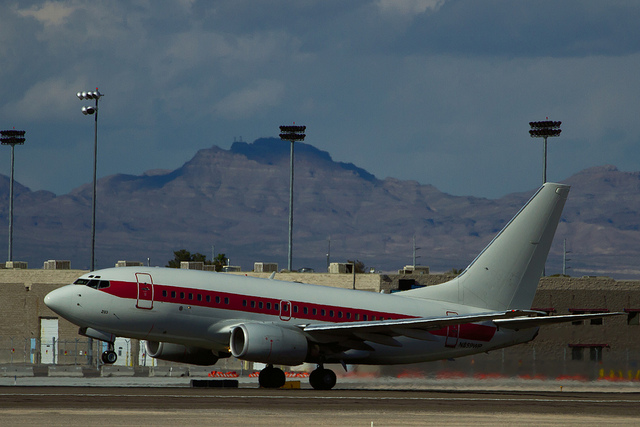<image>Is the vehicle in the photo currently in motion? I am not sure if the vehicle in the photo is currently in motion. Is the vehicle in the photo currently in motion? I don't know if the vehicle in the photo is currently in motion. It can be either moving or not moving. 